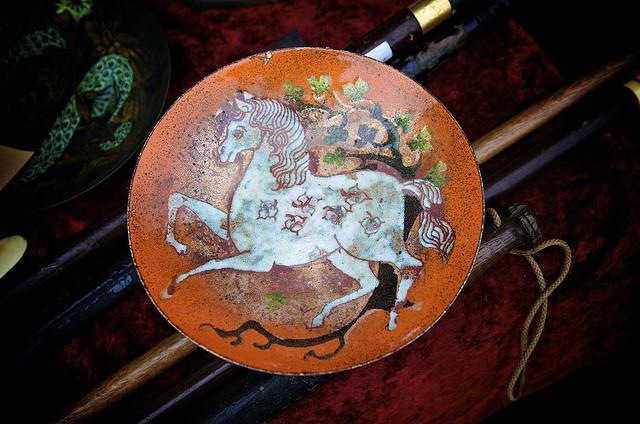How many wooden sticks are there?
Give a very brief answer. 5. How many cherry blossoms adorn the horse?
Give a very brief answer. 6. How many legs are painted white?
Give a very brief answer. 4. 